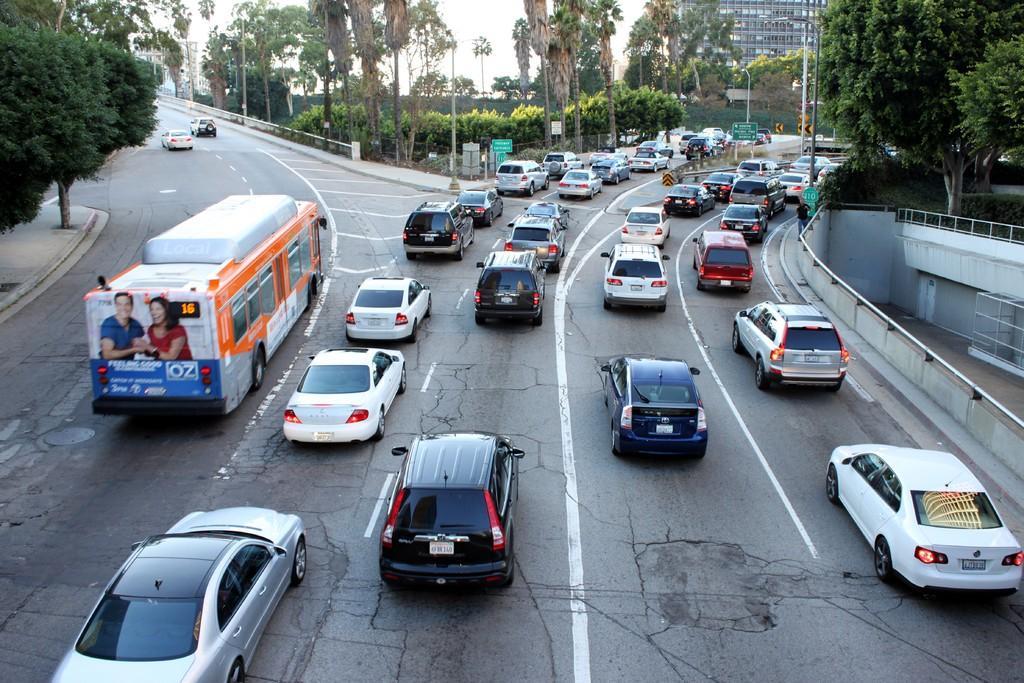Could you give a brief overview of what you see in this image? In this picture we can see some vehicles on the road, there are poles and boards in the middle, in the background we can see trees and a building, there is the sky at the top of the picture, we can also see trees on the left side. 